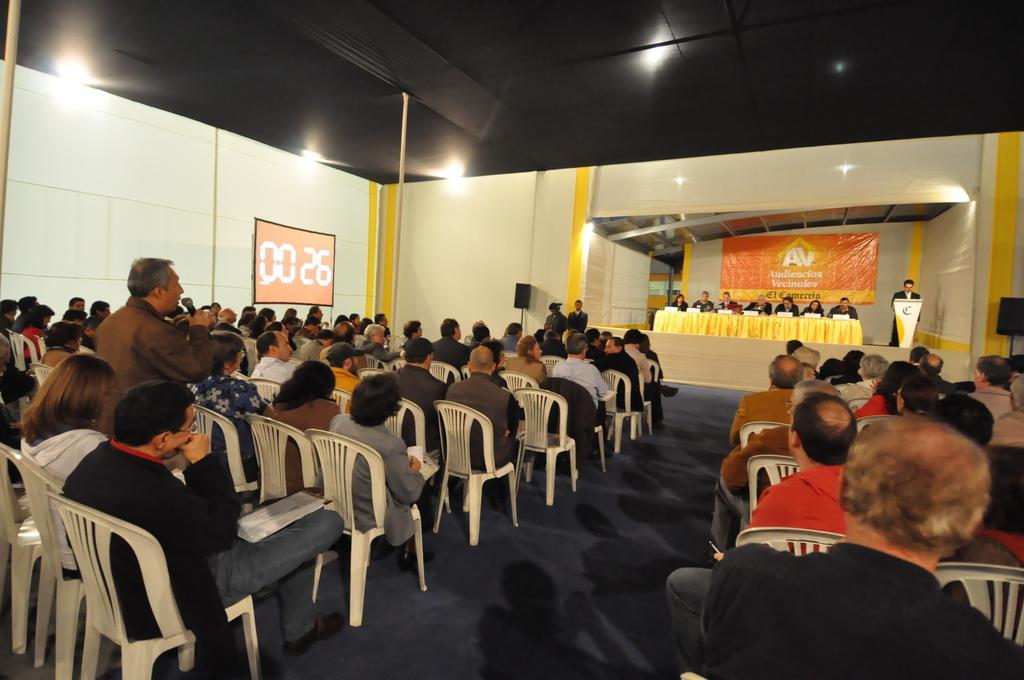Please provide a concise description of this image. In this picture there are several people sitting on the chair. To the left side of the image there is an electronic wall clock attached to the curtain, there is also a stage with people. 